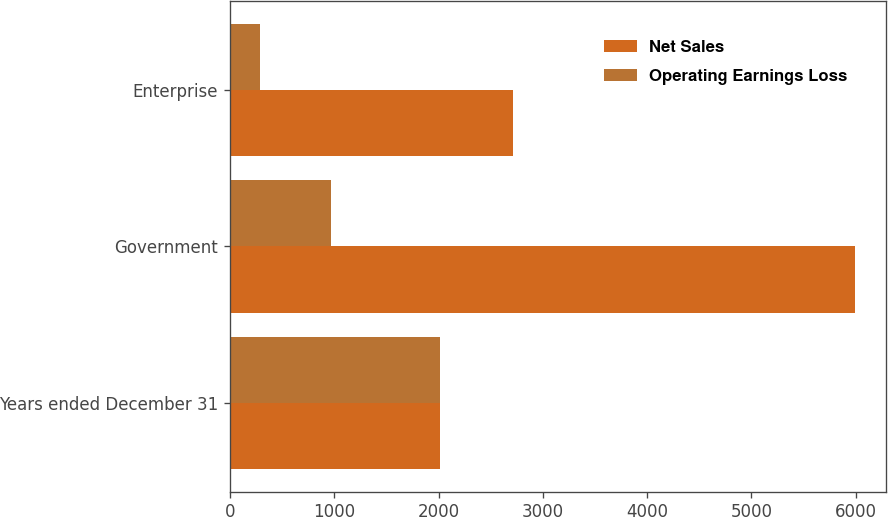<chart> <loc_0><loc_0><loc_500><loc_500><stacked_bar_chart><ecel><fcel>Years ended December 31<fcel>Government<fcel>Enterprise<nl><fcel>Net Sales<fcel>2012<fcel>5989<fcel>2709<nl><fcel>Operating Earnings Loss<fcel>2012<fcel>965<fcel>291<nl></chart> 